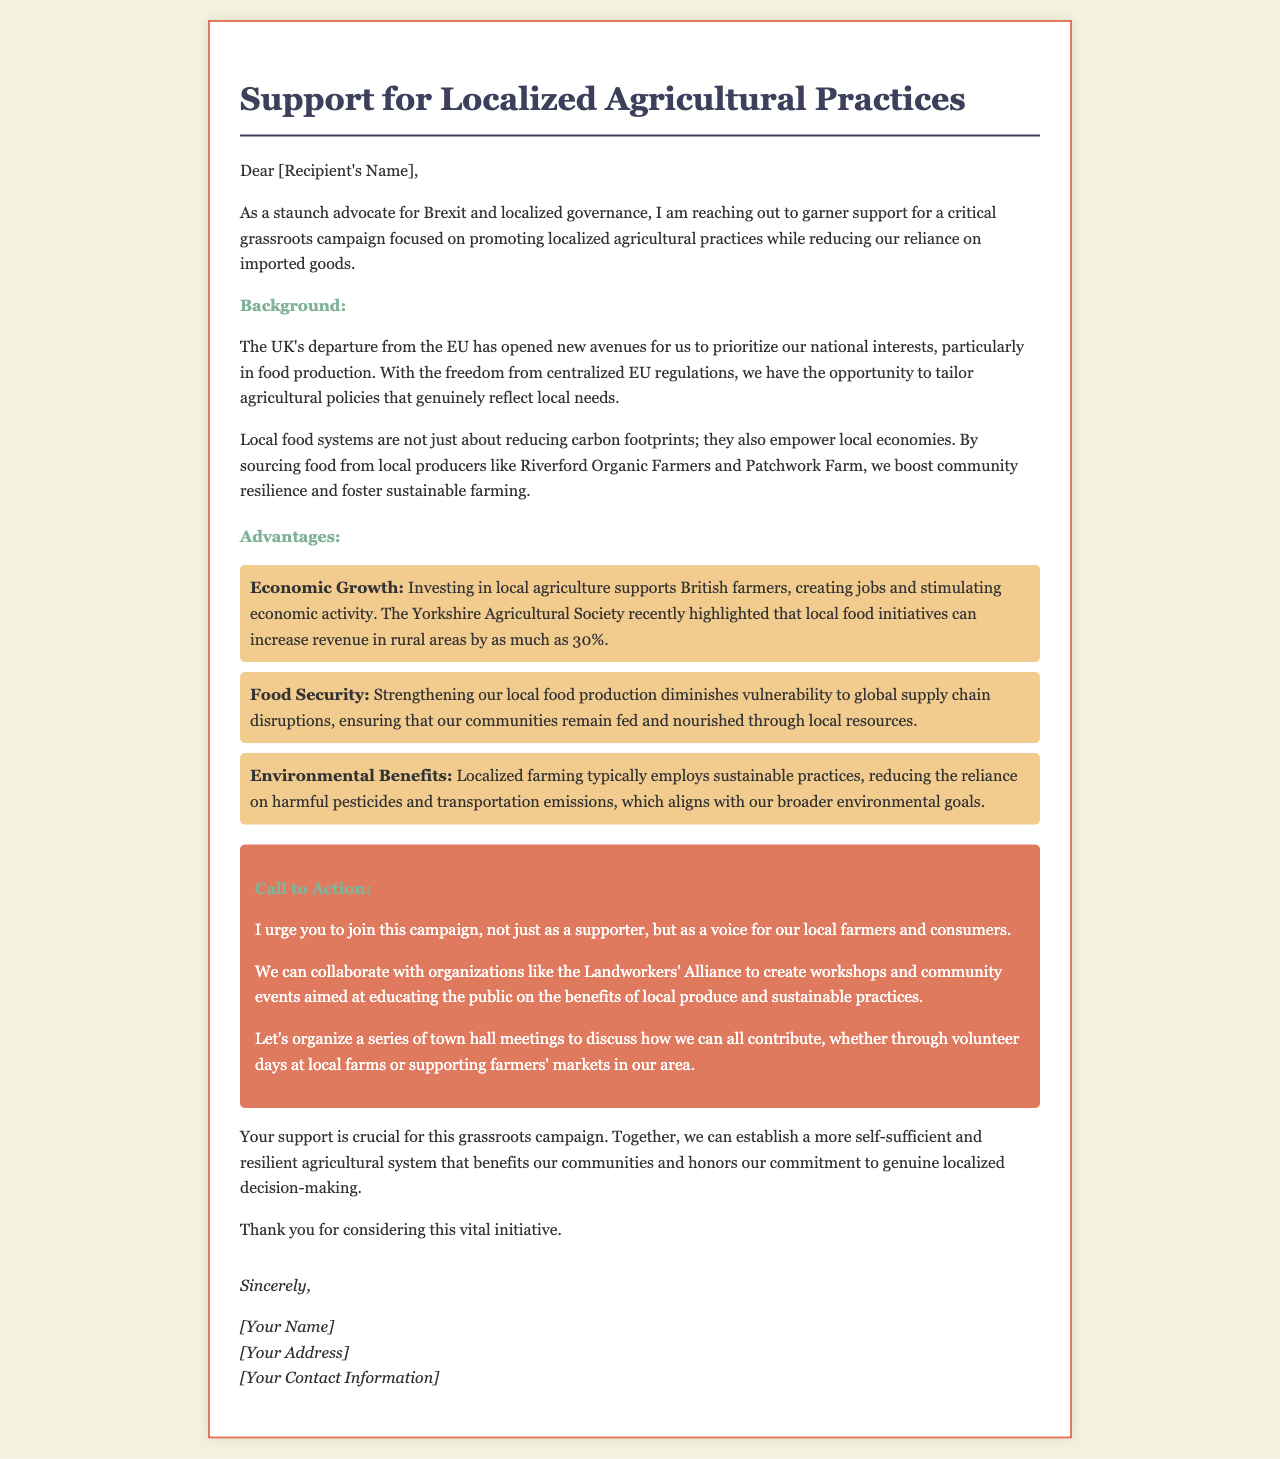What is the letter's main focus? The letter primarily advocates for a grassroots campaign that emphasizes localized agricultural practices and reducing dependence on imported goods.
Answer: localized agricultural practices Who is the recipient of the letter? The letter is directed to an unspecified individual as indicated by "[Recipient's Name]."
Answer: [Recipient's Name] What organization is mentioned as a potential collaborator? The letter mentions collaborating with the Landworkers' Alliance to promote local agriculture and sustainability.
Answer: Landworkers' Alliance What percentage increase in rural revenue is highlighted by the Yorkshire Agricultural Society? The document states that local food initiatives can increase revenue in rural areas by up to 30%.
Answer: 30% What type of meetings does the letter suggest organizing? The letter proposes organizing town hall meetings to discuss support for local farmers and agricultural practices.
Answer: town hall meetings What are the environmental benefits mentioned in the letter? The letter indicates that localized farming typically employs sustainable practices, contributing to environmental preservation.
Answer: sustainable practices What is the call to action in the letter? The letter urges the recipient to join the campaign as a supporter for local farmers and consumers.
Answer: join this campaign What is the first advantage mentioned in the letter? The first advantage discussed in the document centers around economic growth through local agriculture.
Answer: Economic Growth 